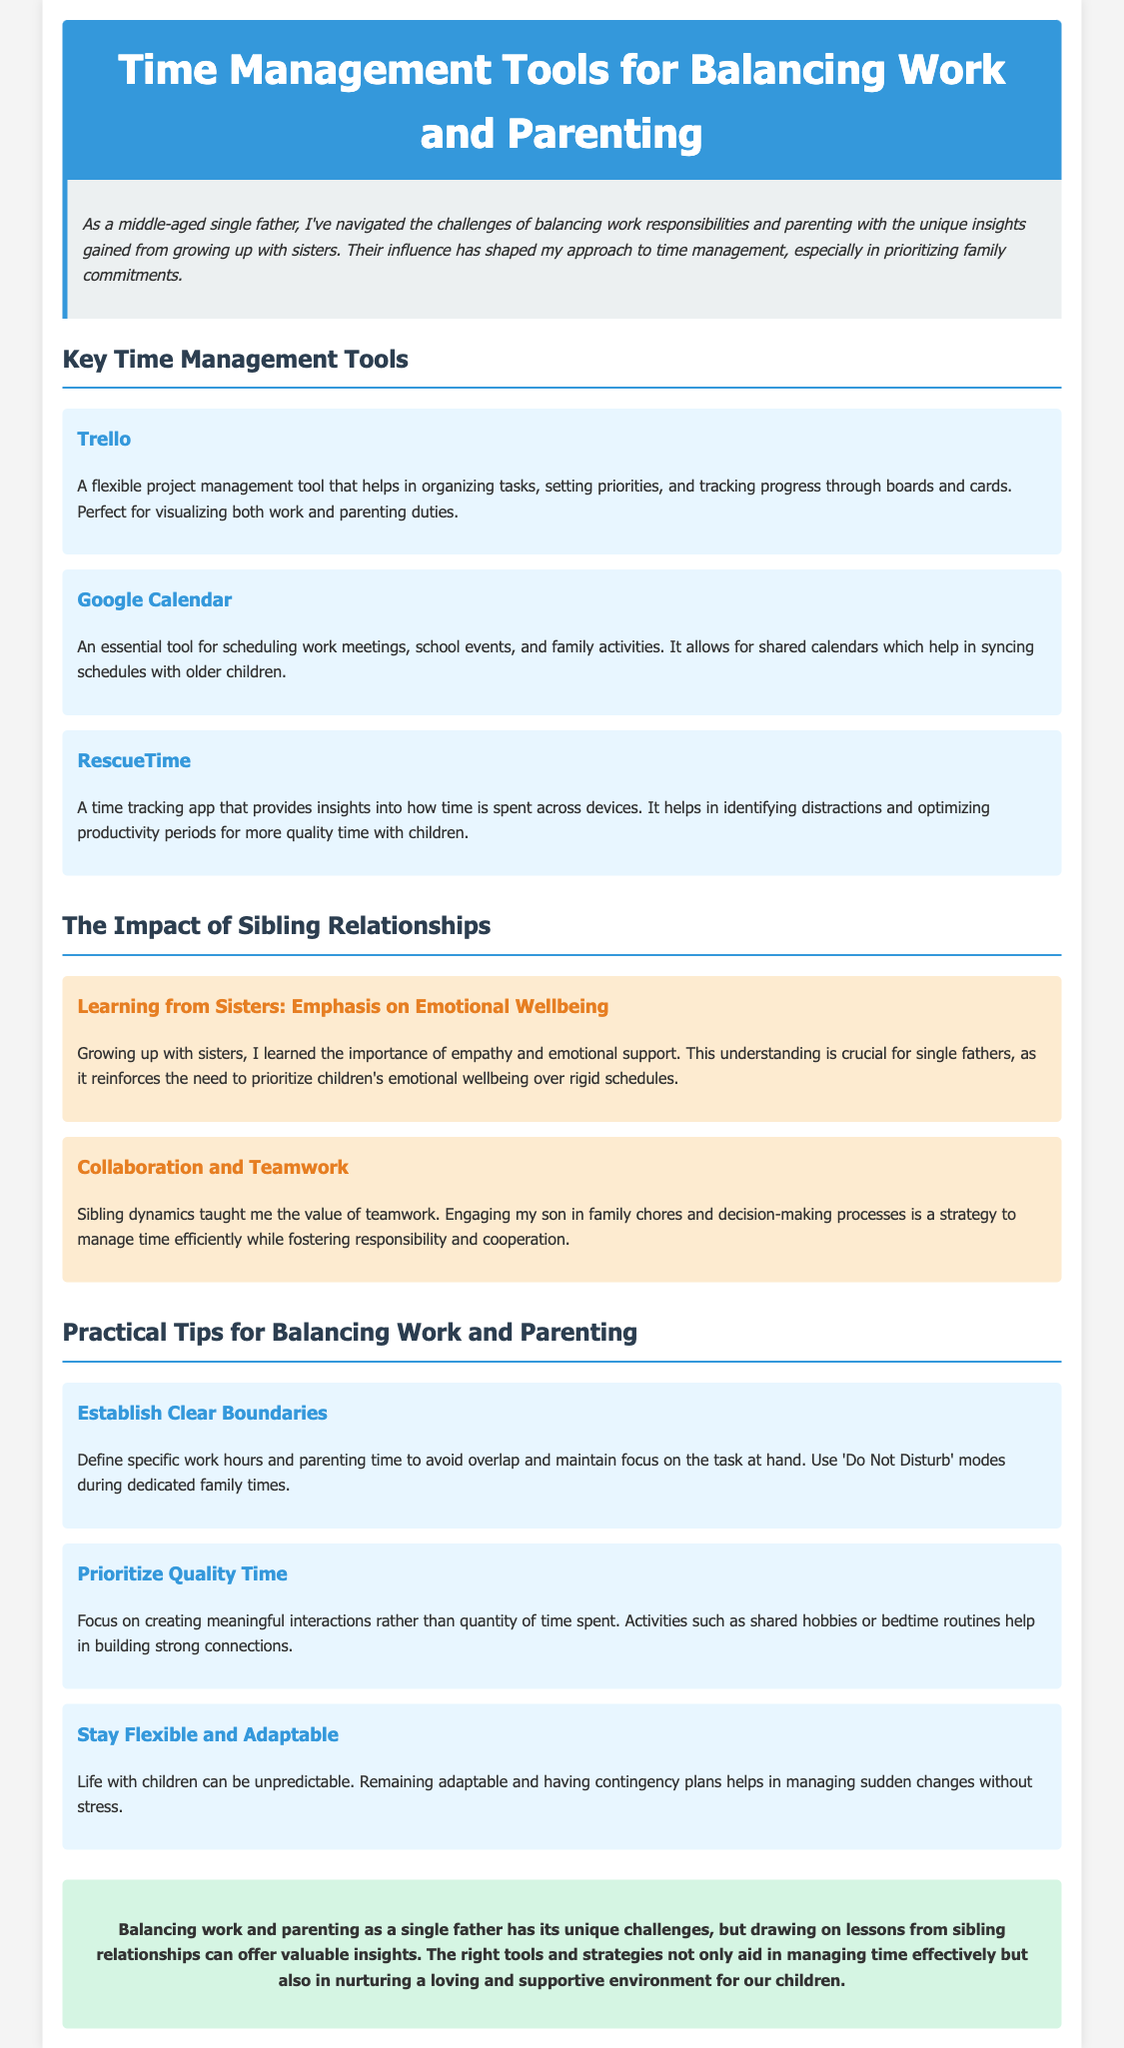What is the title of the document? The title of the document is specified in the header section, which is "Time Management Tools for Balancing Work and Parenting."
Answer: Time Management Tools for Balancing Work and Parenting What tool helps in organizing tasks through boards and cards? The tool mentioned for organizing tasks through boards and cards is Trello.
Answer: Trello What is the primary purpose of Google Calendar? Google Calendar is described as an essential tool for scheduling work meetings, school events, and family activities.
Answer: Scheduling What is emphasized as crucial for single fathers regarding children's needs? The document emphasizes the importance of prioritizing children's emotional wellbeing over rigid schedules.
Answer: Emotional wellbeing What practical tip focuses on establishing specific work hours? The practical tip that focuses on establishing specific work hours is "Establish Clear Boundaries."
Answer: Establish Clear Boundaries How did sibling dynamics influence the author's approach to parenting? The author's approach to parenting was influenced by sibling dynamics through the value of teamwork and collaboration.
Answer: Teamwork and collaboration What does the final section of the document highlight? The final section highlights that balancing work and parenting comes with challenges, but insights from sibling relationships can be valuable.
Answer: Valuable insights What color is used in the header section? The color used in the header section is a shade of blue, specifically #3498db.
Answer: Blue 